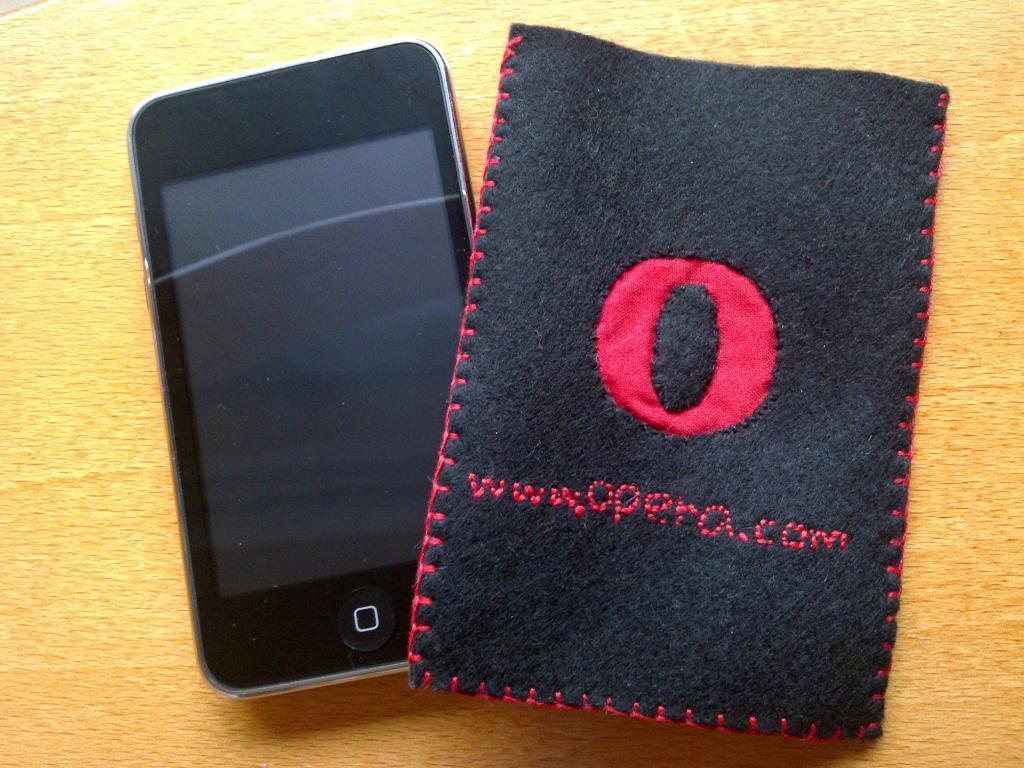Provide a one-sentence caption for the provided image. A small phone next to a cover with the website Opera.com sewn on it. 